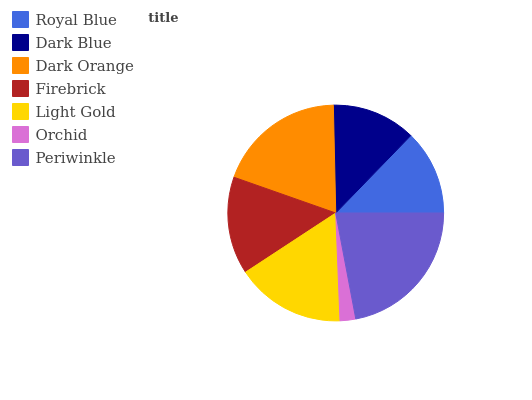Is Orchid the minimum?
Answer yes or no. Yes. Is Periwinkle the maximum?
Answer yes or no. Yes. Is Dark Blue the minimum?
Answer yes or no. No. Is Dark Blue the maximum?
Answer yes or no. No. Is Royal Blue greater than Dark Blue?
Answer yes or no. Yes. Is Dark Blue less than Royal Blue?
Answer yes or no. Yes. Is Dark Blue greater than Royal Blue?
Answer yes or no. No. Is Royal Blue less than Dark Blue?
Answer yes or no. No. Is Firebrick the high median?
Answer yes or no. Yes. Is Firebrick the low median?
Answer yes or no. Yes. Is Periwinkle the high median?
Answer yes or no. No. Is Orchid the low median?
Answer yes or no. No. 